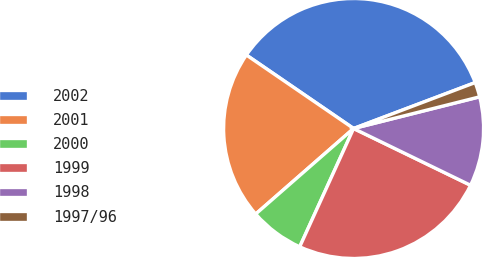Convert chart to OTSL. <chart><loc_0><loc_0><loc_500><loc_500><pie_chart><fcel>2002<fcel>2001<fcel>2000<fcel>1999<fcel>1998<fcel>1997/96<nl><fcel>34.69%<fcel>20.99%<fcel>6.77%<fcel>24.61%<fcel>11.11%<fcel>1.83%<nl></chart> 